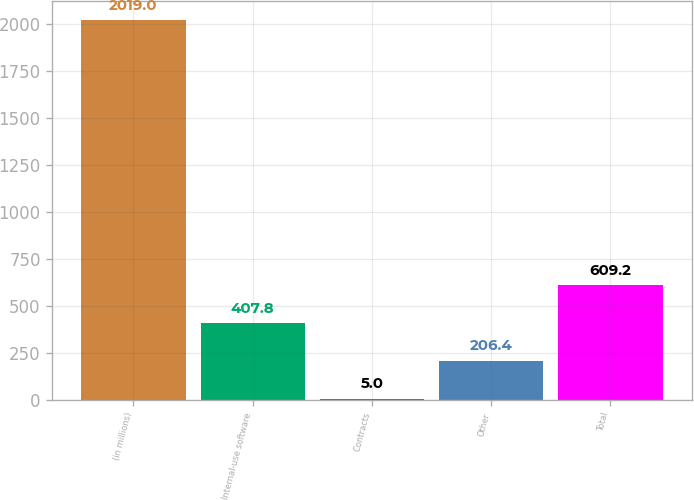Convert chart to OTSL. <chart><loc_0><loc_0><loc_500><loc_500><bar_chart><fcel>(in millions)<fcel>Internal-use software<fcel>Contracts<fcel>Other<fcel>Total<nl><fcel>2019<fcel>407.8<fcel>5<fcel>206.4<fcel>609.2<nl></chart> 